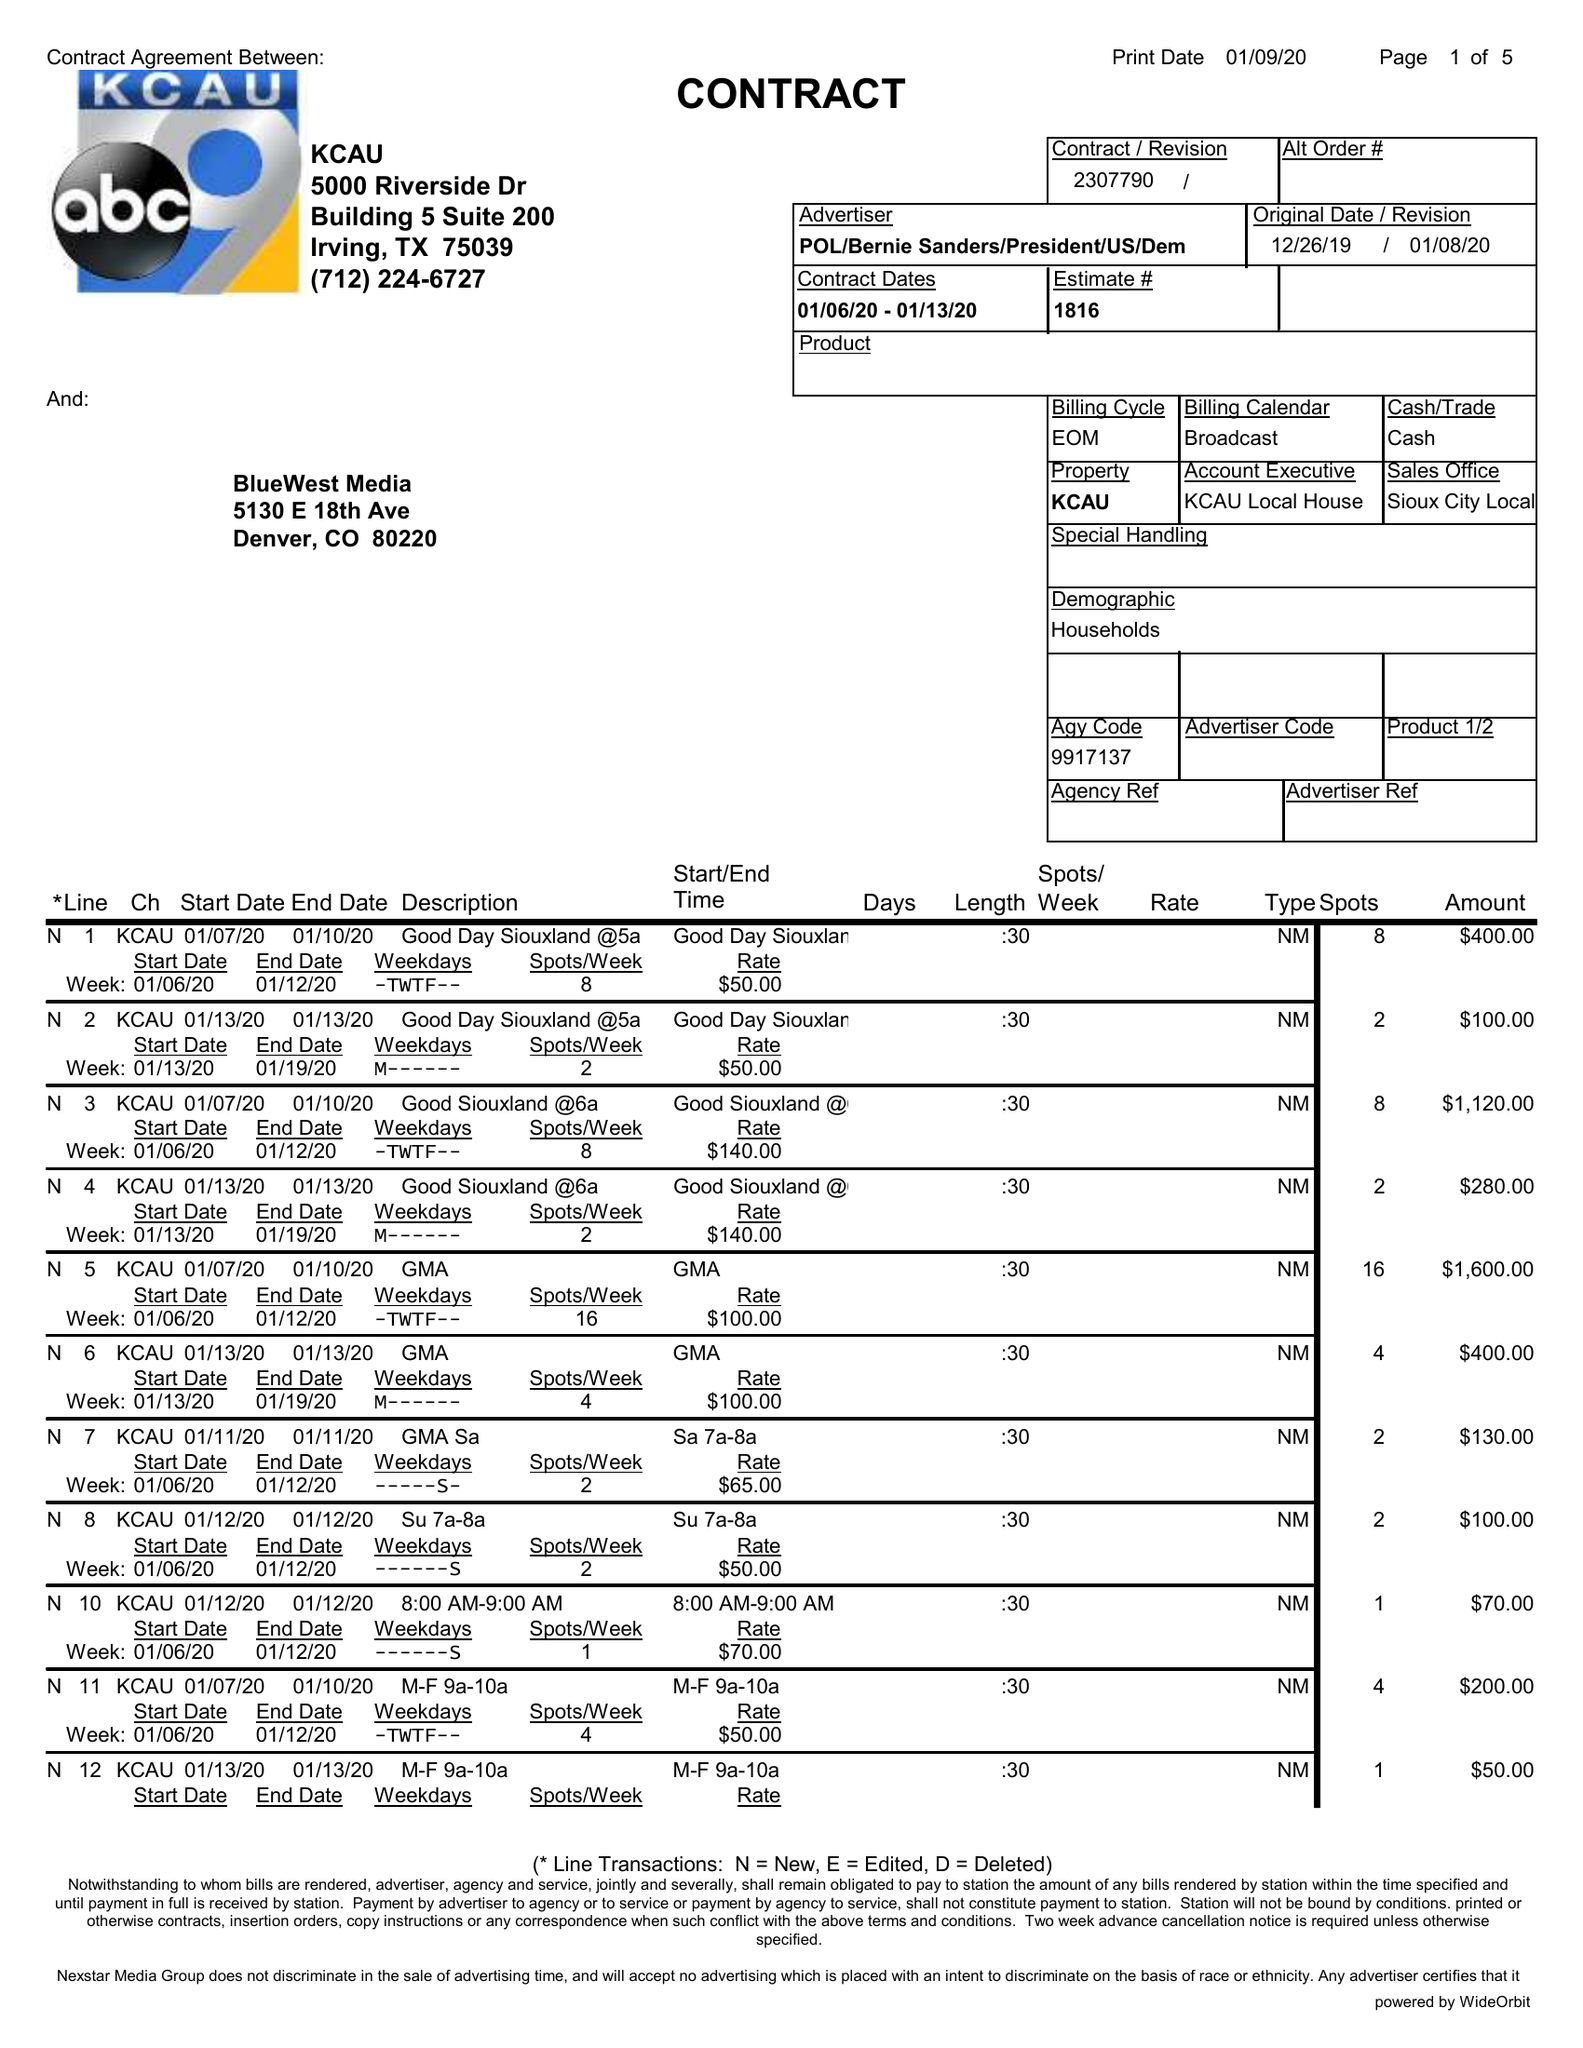What is the value for the gross_amount?
Answer the question using a single word or phrase. 23055.00 